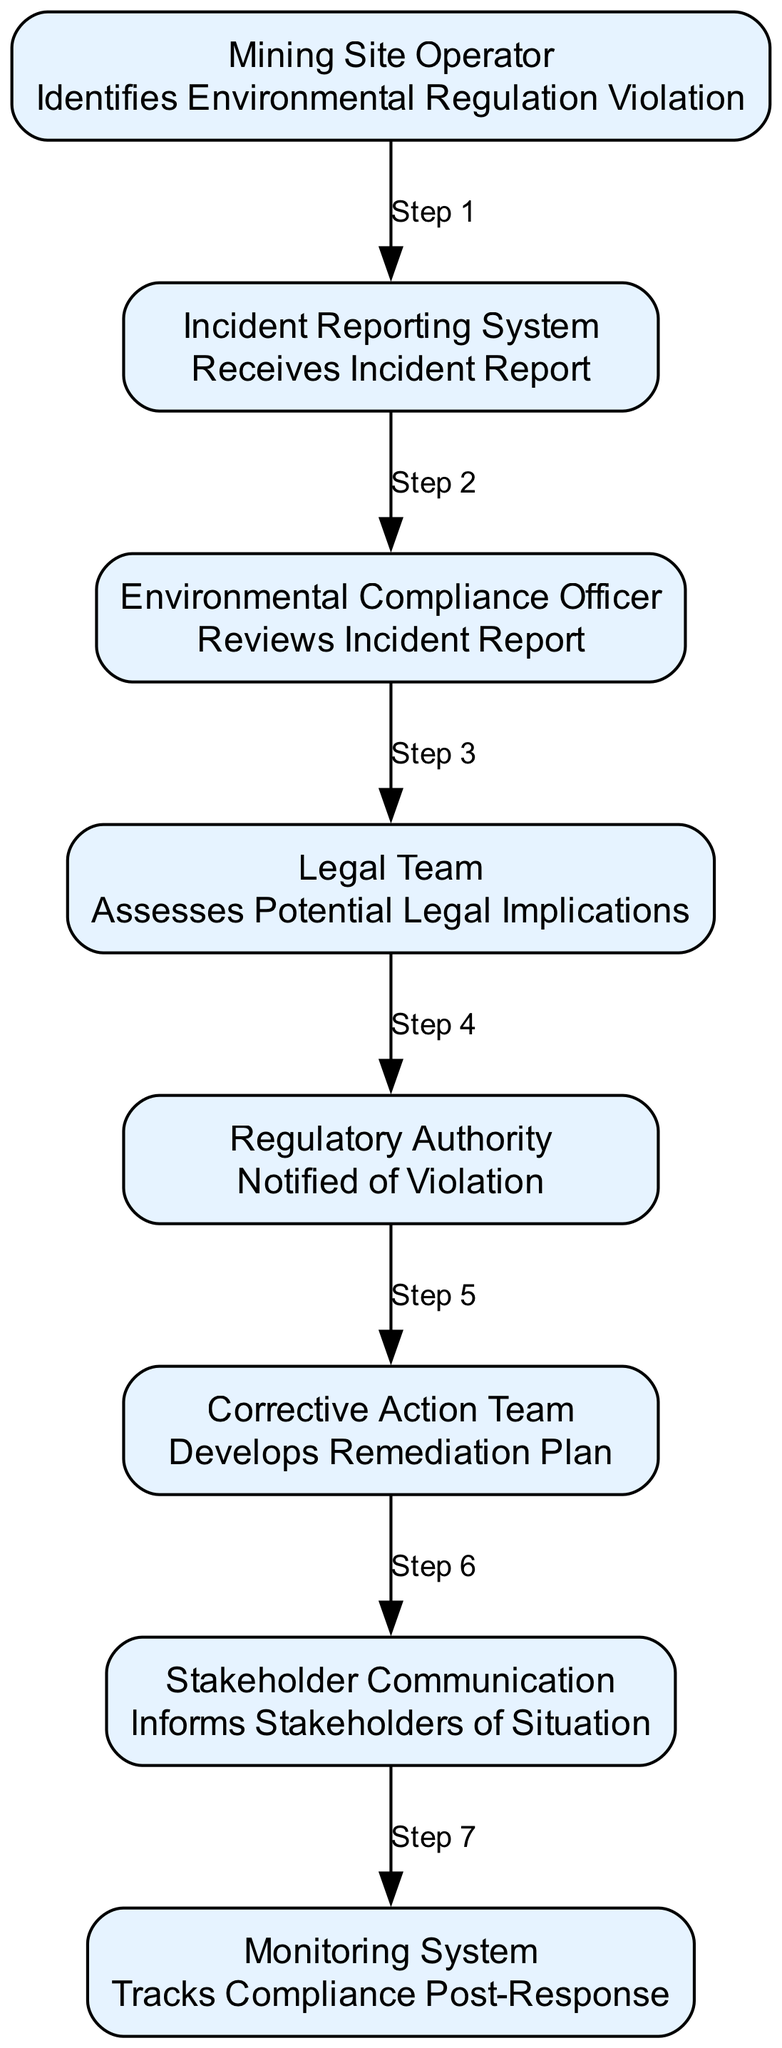What is the first action taken in the diagram? The diagram shows that the first action is performed by the "Mining Site Operator," who "Identifies Environmental Regulation Violation."
Answer: Identifies Environmental Regulation Violation Who receives the incident report? According to the diagram, the "Incident Reporting System" is the entity that "Receives Incident Report."
Answer: Receives Incident Report How many nodes are present in the diagram? By counting the distinct elements listed in the diagram, there are eight nodes which include: Mining Site Operator, Incident Reporting System, Environmental Compliance Officer, Legal Team, Regulatory Authority, Corrective Action Team, Stakeholder Communication, and Monitoring System.
Answer: Eight What step follows the "Environmental Compliance Officer" action? After the "Environmental Compliance Officer," the next action is taken by the "Legal Team," which "Assesses Potential Legal Implications."
Answer: Assesses Potential Legal Implications What happens after the violation is identified? The process indicates that after identifying the violation, the "Incident Reporting System" receives the incident report, converting the identified issue into a formal report for review.
Answer: Receives Incident Report What is the last action in the workflow? The final action as per the diagram is carried out by the "Monitoring System," which "Tracks Compliance Post-Response."
Answer: Tracks Compliance Post-Response Which team develops the remediation plan? The diagram specifically states that the "Corrective Action Team" is responsible for "Develops Remediation Plan."
Answer: Develops Remediation Plan How does the "Regulatory Authority" get involved? The "Regulatory Authority" is notified as a result of the violation identified by the operator, indicating their involvement in the compliance process as a step after reporting.
Answer: Notified of Violation 